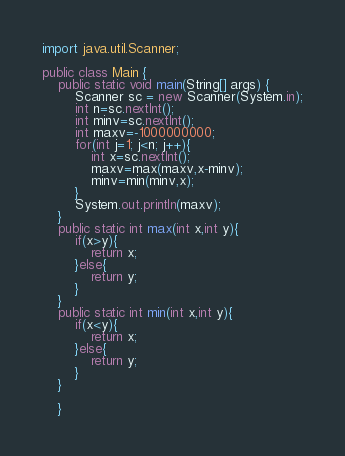<code> <loc_0><loc_0><loc_500><loc_500><_Java_>import java.util.Scanner;

public class Main {
	public static void main(String[] args) {
		Scanner sc = new Scanner(System.in);
		int n=sc.nextInt();
		int minv=sc.nextInt();
		int maxv=-1000000000;
		for(int j=1; j<n; j++){
			int x=sc.nextInt();
			maxv=max(maxv,x-minv);
			minv=min(minv,x);
		}
		System.out.println(maxv);
	}
	public static int max(int x,int y){
		if(x>y){
			return x;
		}else{
			return y;
		}
	}
	public static int min(int x,int y){
		if(x<y){
			return x;
		}else{
			return y;
		}
	}

	}
</code> 